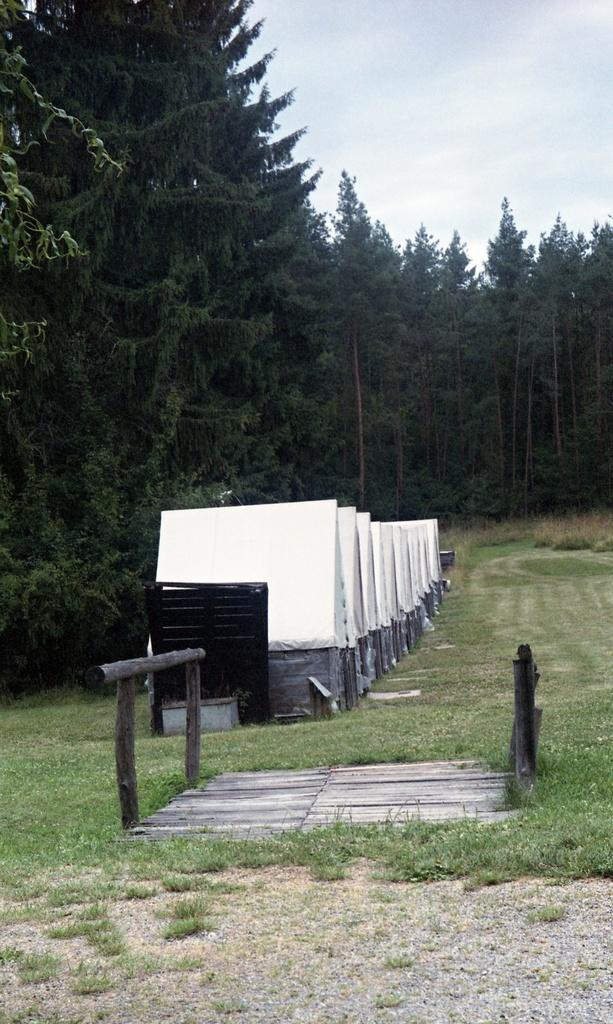Describe this image in one or two sentences. In this image, we can see sheds, trees, logs and a board. At the top, there is sky and at the bottom, there is ground. 